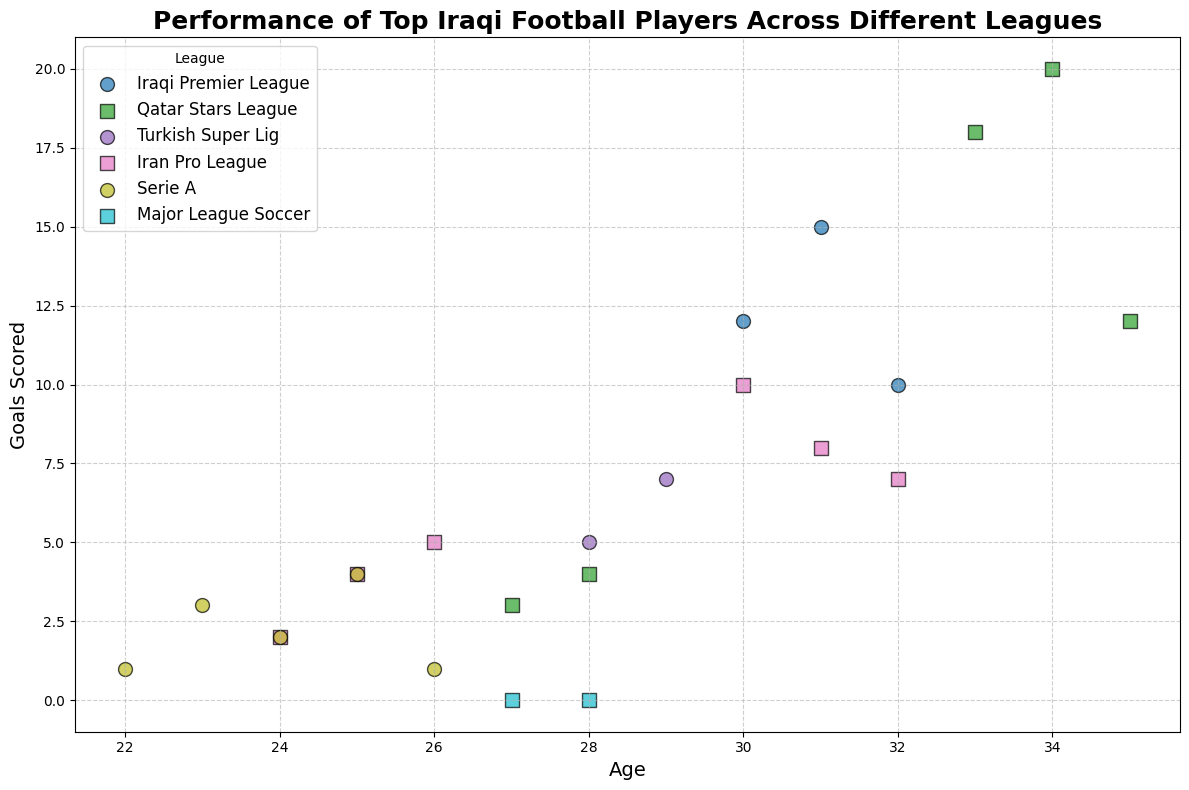What is the overall trend in the number of goals scored by Younis Mahmoud as he aged? By examining the plot, we can see Younis Mahmoud's goals in both the Iraqi Premier League and Qatar Stars League. He scored more goals when he moved to the Qatar Stars League, especially in his early 30s. So, while there are fluctuations, the overall trend shows he scored more goals in his early years in the Qatar Stars League compared to the Iraqi Premier League.
Answer: Increasing then varying Did Hawar Mulla Mohammed score more goals in the Iranian Pro League or the Turkish Super Lig? The plot shows the points for both leagues. In the Turkish Super Lig, he scored 5 and 7 goals, while in the Iranian Pro League, he scored 10, 8, and 7 goals. Summing these up, he scored 12 in Turkey and 25 in Iran.
Answer: Iranian Pro League Which player had the most consistent performance in terms of goals scored over the years? By looking at the spread of data points for each player, it appears that Ali Adnan's points are closely packed, indicating similar goal counts every year, mostly between 0 and 4 goals.
Answer: Ali Adnan How do Ali Adnan’s goal counts differ between Serie A and Major League Soccer? The plot shows Ali Adnan's goals in Serie A and Major League Soccer. In Serie A, he scored 1, 3, 2, 4, and 1 goals, while in MLS, he scored 0 goals in both years.
Answer: More in Serie A How does the performance of Bashar Resan in the Iran Pro League compare to his performance in the Qatar Stars League? Bashar Resan scored 2, 4, and 5 goals in the Iran Pro League and 3 and 4 goals in the Qatar Stars League. Summing up, he scored 11 in Iran and 7 in Qatar. Therefore, he scored more goals in the Iran Pro League.
Answer: Better in Iran Pro League At what age did Younis Mahmoud score the most goals, and in which league? From the plot, Younis Mahmoud scored the most goals (20) at age 34 in the Qatar Stars League.
Answer: Age 34, Qatar Stars League Which league has the highest variety in the number of goals scored? By looking for the league with the widest range of points vertically, the Qatar Stars League has significant variability, with goals ranging from 3 to 20.
Answer: Qatar Stars League Can you identify the youngest player’s goals trend? The youngest player is Ali Adnan, starting at age 22. His performance in Serie A shows a fluctuating number of goals, with values like 1, 3, 2, 4, and 1, and then scoring no goals in MLS in subsequent years. Overall, there is a downward trend.
Answer: Downward trend Which age group has the highest average goals? By evaluating the ages and goals: Younis Mahmoud (30-35), Hawar Mulla Mohammed (28-32), Ali Adnan (22-28), and Bashar Resan (24-28). Younis Mahmoud scored quite high between 33-34 in the Qatar Stars League, leading these age groups with higher average goals compared to others.
Answer: 33-34 years How does the scoring trend change for players who switched leagues? Younis Mahmoud showed improvement in goals after moving to the Qatar Stars League, while Hawar Mulla Mohammed's goals decreased slightly when switching to the Iranian Pro League, and Ali Adnan scored less after switching to the MLS.
Answer: Varies: Increases for Younis, decreases for Ali and Hawar 